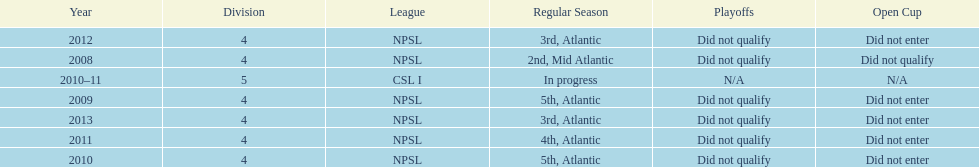In what year only did they compete in division 5 2010-11. 